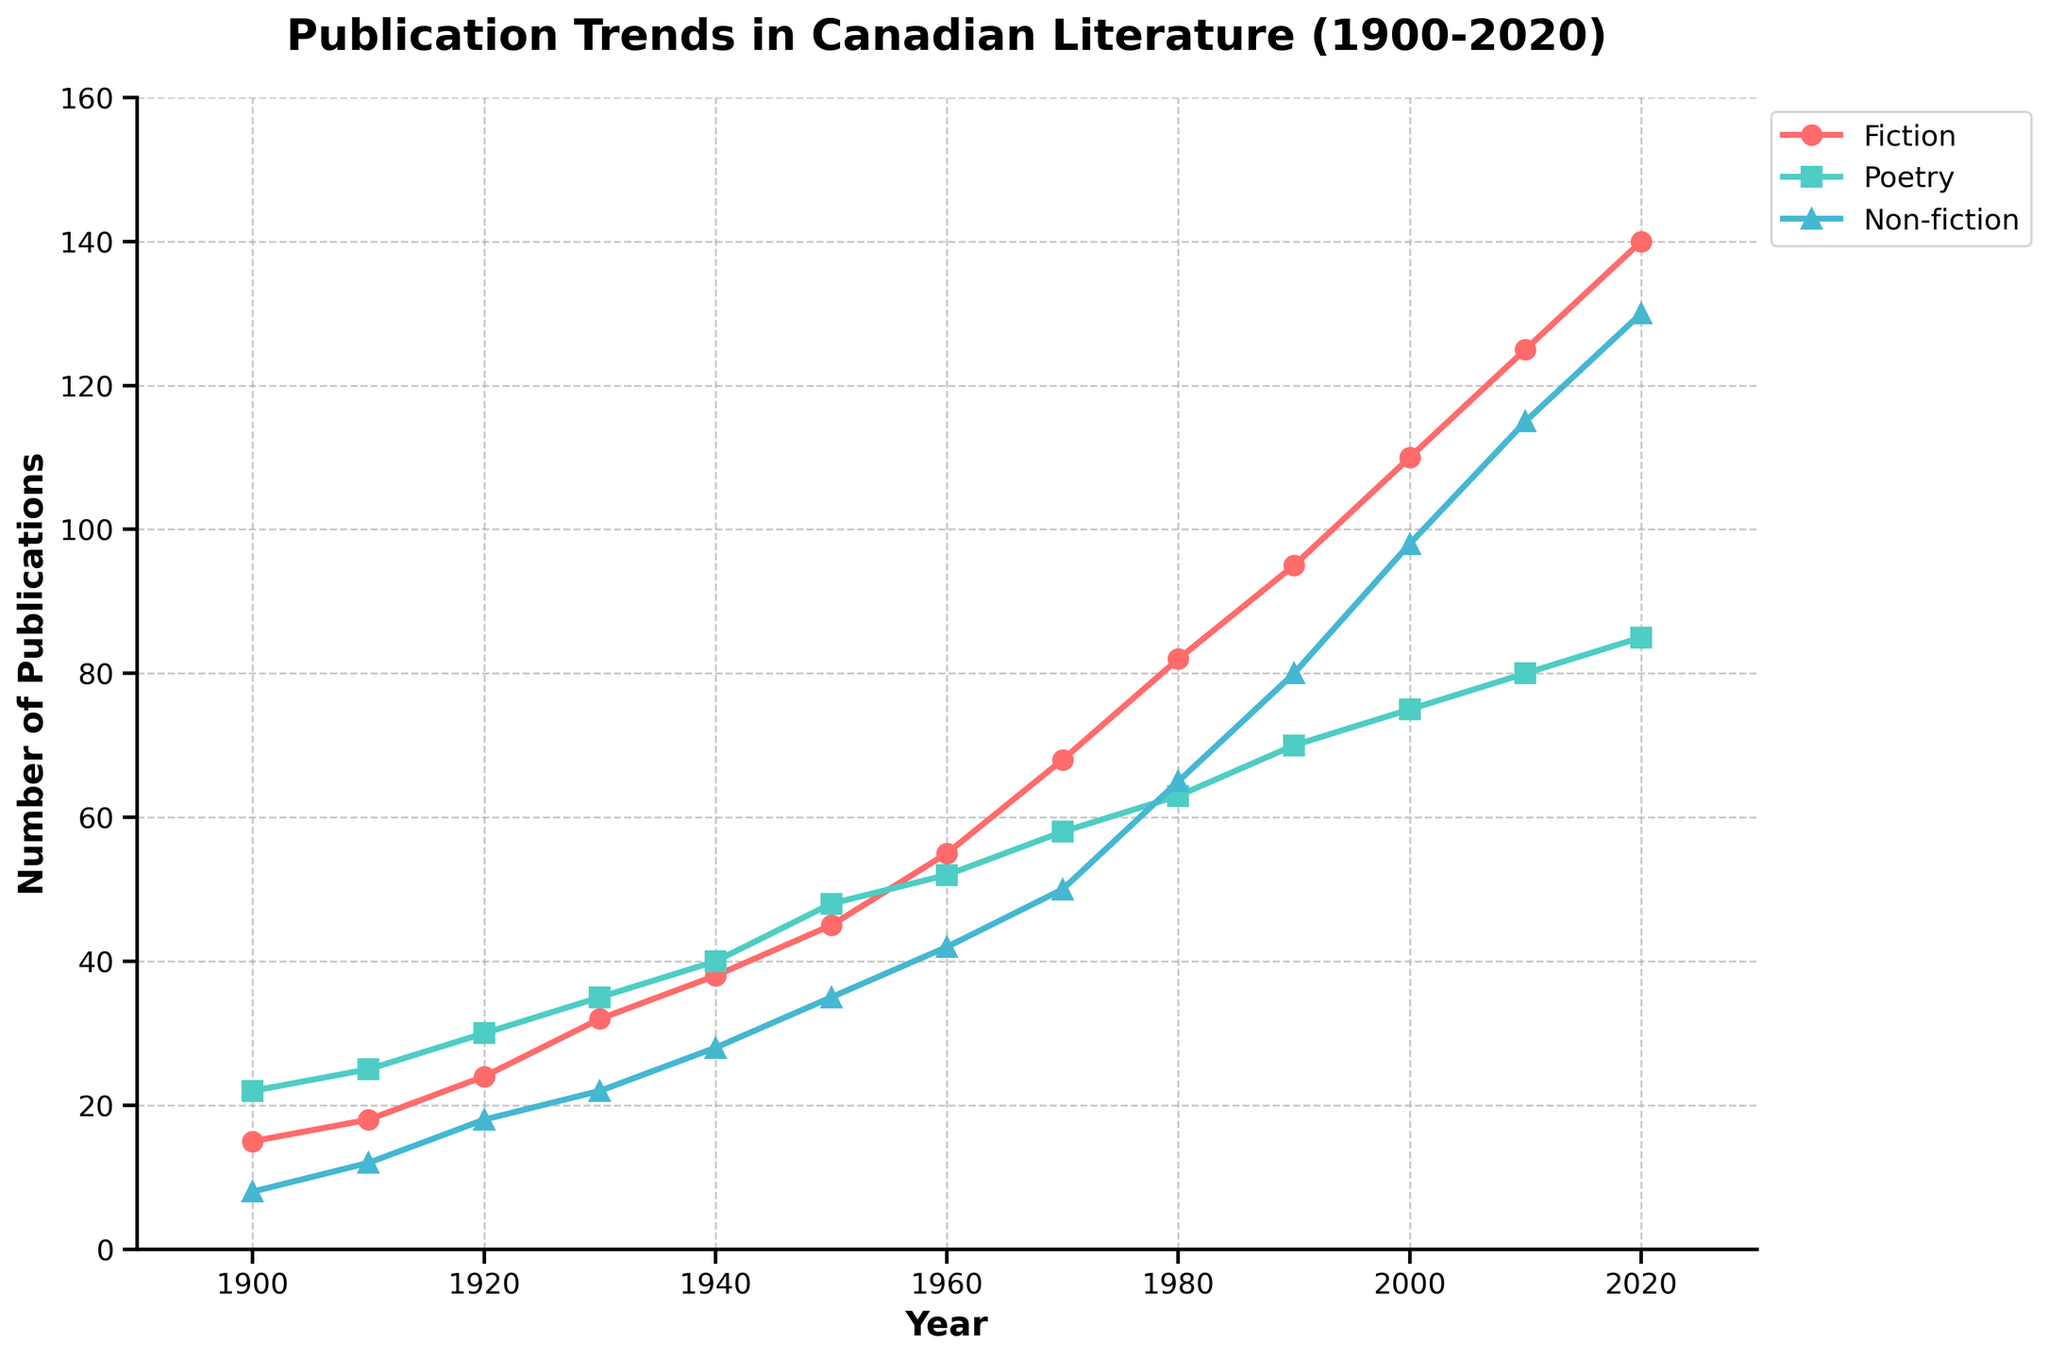What's the overall trend in fiction publications from 1900 to 2020? The trend line for fiction publications is consistently increasing over the period from 1900 to 2020. In 1900, the number of fiction publications was 15, and it steadily rises to 140 by 2020.
Answer: Increasing Which genre saw the highest number of publications in 2020? In the year 2020, the genre with the highest number of publications is Fiction, with 140 publications, which is higher than both Poetry (85) and Non-fiction (130).
Answer: Fiction In which decade did poetry publications surpass 50 for the first time? Poetry publications first surpassed 50 in the 1950s, specifically in 1950, when there were 48 poetry publications, and then in 1960, the number jumps to 52.
Answer: 1960s Between 1910 and 1950, which genre had the largest increase in the number of publications? For Fiction: 1950-1910 = 45-18 = 27, for Poetry: 1950-1910 = 48-25 = 23, and for Non-fiction: 1950-1910 = 35-12 = 23. Fiction had the largest increase.
Answer: Fiction How many more fiction publications were there in 1980 compared to 1900? In 1980, Fiction had 82 publications, and in 1900 it had 15 publications. The increase is 82 - 15 = 67 more publications.
Answer: 67 Which genre had the slowest growth in publication numbers from 1900 to 1940? Growth for each genre from 1900 to 1940: Fiction (38-15 = 23), Poetry (40-22 = 18), Non-fiction (28-8 = 20). Poetry had the slowest growth.
Answer: Poetry Between 2000 and 2020, how many more non-fiction publications were there compared to poetry publications? In 2020, Non-fiction had 130 publications while Poetry had 85, giving a difference of 130 - 85 = 45 more non-fiction publications.
Answer: 45 What is the ratio of fiction to non-fiction publications in the year 2000? In 2000, Fiction had 110 publications and Non-fiction had 98 publications. The ratio is 110/98, which simplifies to approximately 1.12.
Answer: 1.12 What decade saw the largest increase in non-fiction publications? Calculating increases per decade for Non-fiction: 1910-1900 = 4, 1920-1910 = 6, 1930-1920 = 4, 1940-1930 = 6, 1950-1940 = 7, 1960-1950 = 7, 1970-1960 = 8, 1980-1970 = 15, 1990-1980 = 15, 2000-1990 = 18, 2010-2000 = 17, 2020-2010 = 15. The 1980s and 2000s saw an increase of 15 and 18 respectively, with the largest being in the 2000s.
Answer: 2000s By what factor did the number of poetry publications increase from 1900 to 2020? The number of poetry publications in 1900 was 22, and in 2020 it was 85. The factor increase is 85/22 ≈ 3.86.
Answer: 3.86 